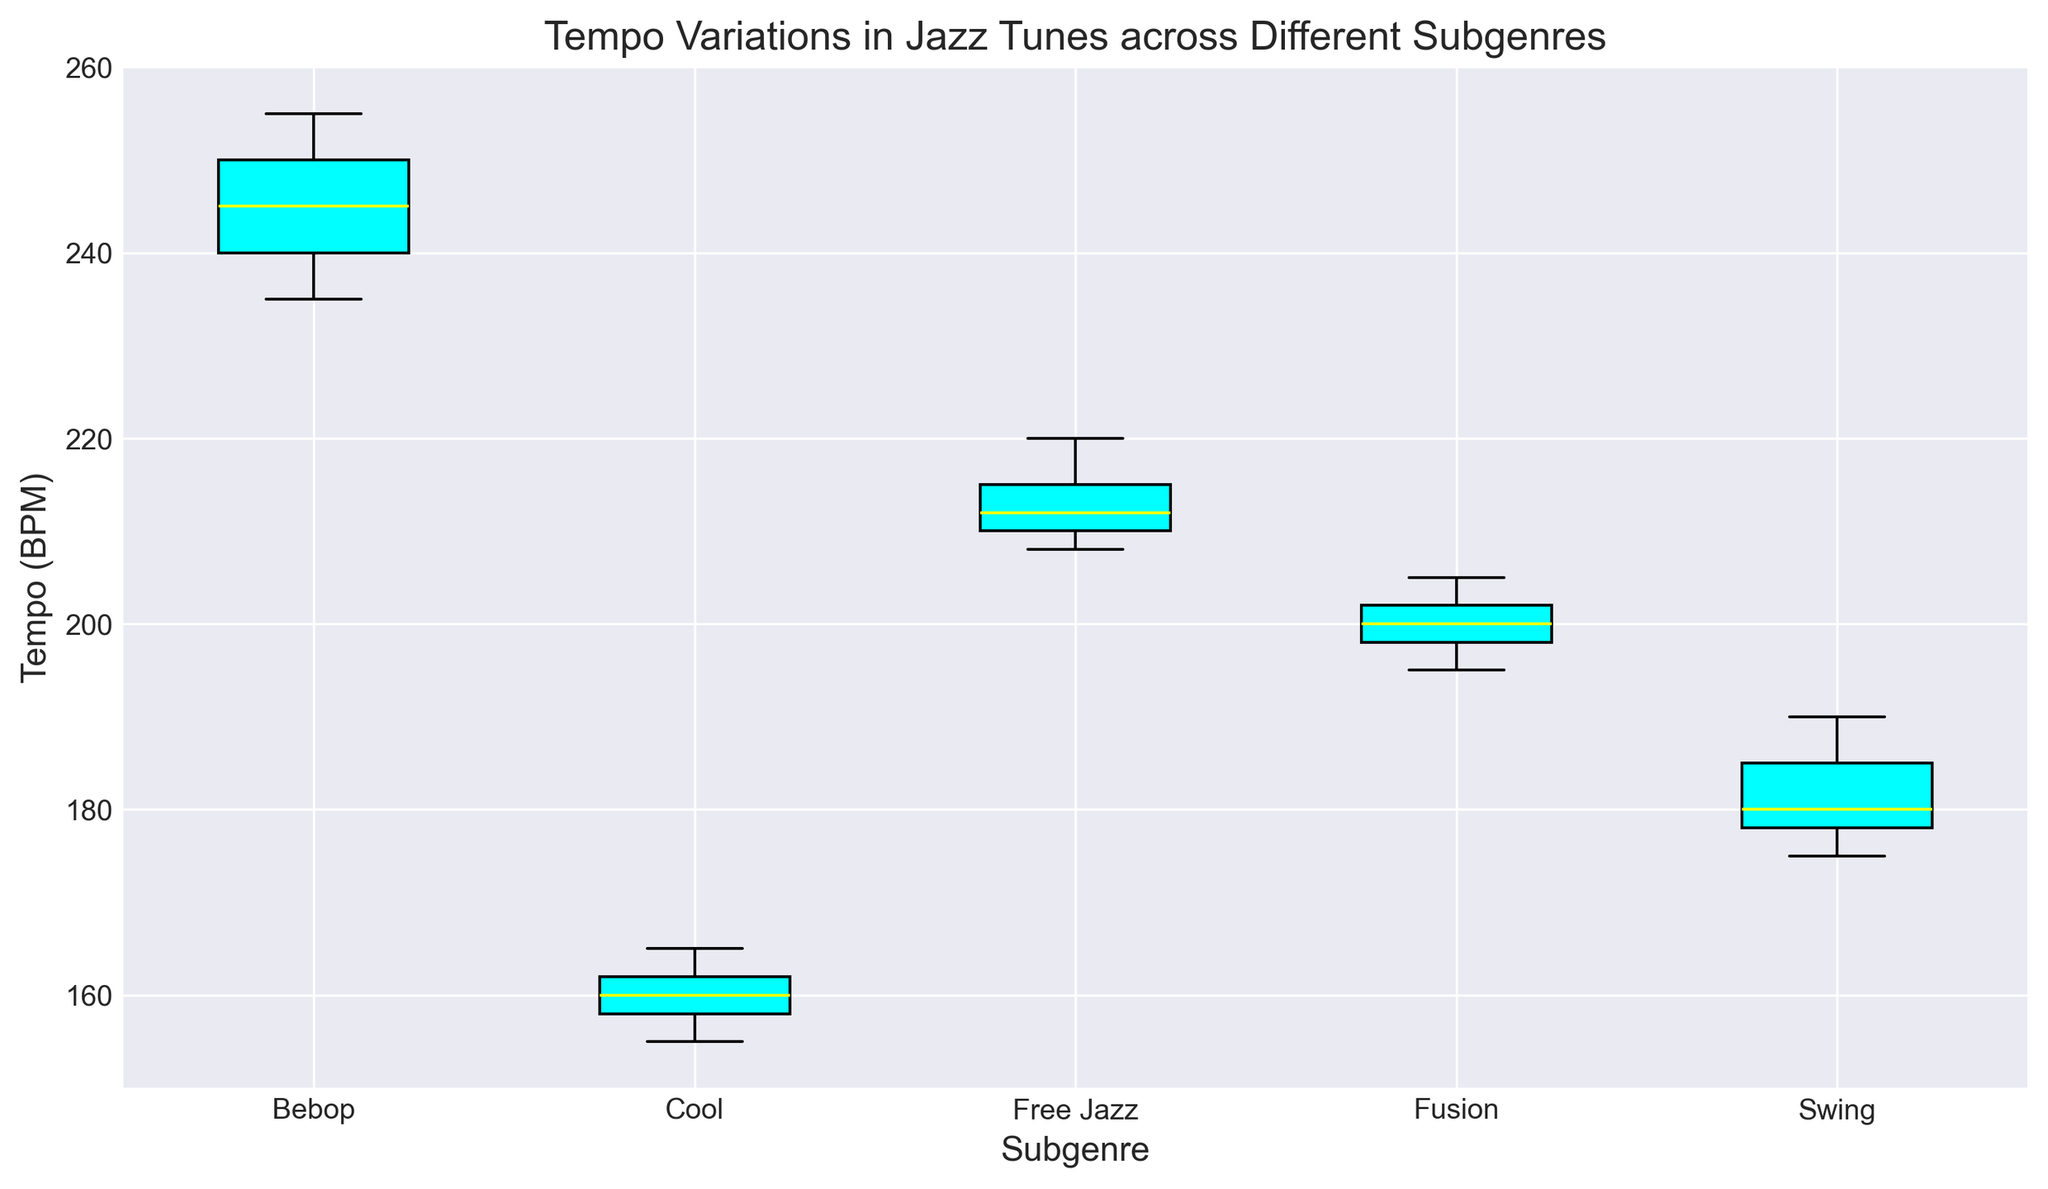What is the range of tempo in the Bebop subgenre? To find the range, identify the highest and lowest values in the Bebop subgenre data. The highest value is 255, and the lowest is 235. Calculate the range by subtracting the lowest from the highest: 255 - 235 = 20.
Answer: 20 Which subgenre has the lowest median tempo? To determine the lowest median tempo, examine the median line (typically a bold line) of each box. Cool has the lowest median, which is at 160 BPM.
Answer: Cool Is the spread of tempos wider in Bebop or Swing? To determine the spread, look at the width of the boxes and the length of the whiskers. Bebop shows a broader spread with a wider box and longer whiskers compared to Swing.
Answer: Bebop What is the median tempo of the Free Jazz subgenre? Locate the median line within the box for Free Jazz. The median line in Free Jazz is at approximately 212 BPM.
Answer: 212 Which subgenre has the most consistent tempos? The consistency of tempos can be inferred from the interquartile range (IQR), represented by the height of the box. The Cool subgenre has the smallest box indicating the most consistent tempos.
Answer: Cool Which subgenre has the highest upper quartile tempo? The upper quartile (75th percentile) is the top line of the box. The Bebop subgenre has the highest upper quartile, which appears to be at 250 BPM.
Answer: Bebop How does the median tempo of Fusion compare with the median tempo of Swing? Compare the median lines of the Fusion and Swing boxes. Fusion's median is at 200 BPM, while Swing's is around 179 BPM. Fusion's median tempo is higher than Swing's.
Answer: Fusion's median is higher What color represents the box plots? The color of the boxes in the plot is clearly mentioned as cyan.
Answer: Cyan Which subgenre's tempo range overlaps with Free Jazz's tempo range? Compare the whiskers and boxes of other subgenres with Free Jazz. Fusion shows some overlap in its upper quartile with Free Jazz's lower quartile.
Answer: Fusion 